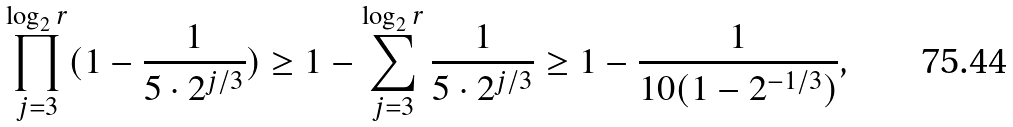<formula> <loc_0><loc_0><loc_500><loc_500>\prod _ { j = 3 } ^ { \log _ { 2 } r } ( 1 - \frac { 1 } { 5 \cdot 2 ^ { j / 3 } } ) \geq 1 - \sum _ { j = 3 } ^ { \log _ { 2 } r } \frac { 1 } { 5 \cdot 2 ^ { j / 3 } } \geq 1 - \frac { 1 } { 1 0 ( 1 - 2 ^ { - 1 / 3 } ) } ,</formula> 